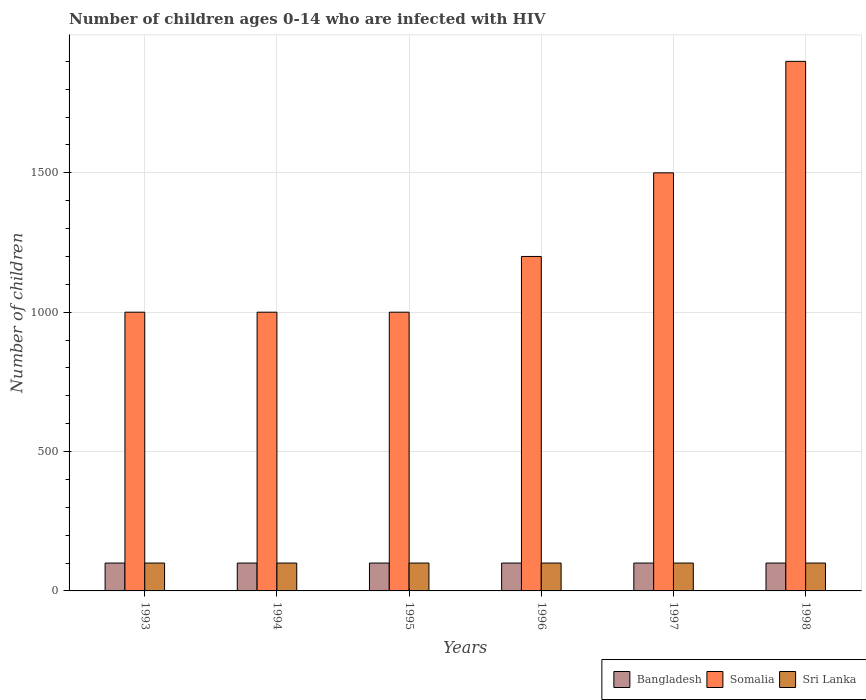Are the number of bars per tick equal to the number of legend labels?
Your answer should be very brief. Yes. How many bars are there on the 1st tick from the right?
Your response must be concise. 3. What is the label of the 2nd group of bars from the left?
Offer a very short reply. 1994. What is the number of HIV infected children in Sri Lanka in 1995?
Your answer should be compact. 100. Across all years, what is the maximum number of HIV infected children in Somalia?
Provide a succinct answer. 1900. Across all years, what is the minimum number of HIV infected children in Somalia?
Your answer should be compact. 1000. In which year was the number of HIV infected children in Bangladesh minimum?
Your answer should be compact. 1993. What is the total number of HIV infected children in Bangladesh in the graph?
Give a very brief answer. 600. What is the difference between the number of HIV infected children in Somalia in 1993 and the number of HIV infected children in Sri Lanka in 1997?
Provide a short and direct response. 900. What is the average number of HIV infected children in Somalia per year?
Your response must be concise. 1266.67. In how many years, is the number of HIV infected children in Somalia greater than 800?
Ensure brevity in your answer.  6. Is the difference between the number of HIV infected children in Bangladesh in 1994 and 1995 greater than the difference between the number of HIV infected children in Sri Lanka in 1994 and 1995?
Your response must be concise. No. In how many years, is the number of HIV infected children in Bangladesh greater than the average number of HIV infected children in Bangladesh taken over all years?
Offer a terse response. 0. What does the 2nd bar from the right in 1996 represents?
Your answer should be very brief. Somalia. Are all the bars in the graph horizontal?
Provide a succinct answer. No. How many years are there in the graph?
Provide a short and direct response. 6. Are the values on the major ticks of Y-axis written in scientific E-notation?
Provide a short and direct response. No. Does the graph contain any zero values?
Your answer should be compact. No. Does the graph contain grids?
Provide a succinct answer. Yes. How many legend labels are there?
Keep it short and to the point. 3. How are the legend labels stacked?
Offer a very short reply. Horizontal. What is the title of the graph?
Provide a succinct answer. Number of children ages 0-14 who are infected with HIV. What is the label or title of the Y-axis?
Offer a terse response. Number of children. What is the Number of children in Sri Lanka in 1993?
Ensure brevity in your answer.  100. What is the Number of children of Bangladesh in 1994?
Give a very brief answer. 100. What is the Number of children in Sri Lanka in 1994?
Make the answer very short. 100. What is the Number of children of Somalia in 1995?
Your answer should be very brief. 1000. What is the Number of children of Sri Lanka in 1995?
Ensure brevity in your answer.  100. What is the Number of children in Bangladesh in 1996?
Offer a terse response. 100. What is the Number of children in Somalia in 1996?
Ensure brevity in your answer.  1200. What is the Number of children of Sri Lanka in 1996?
Your answer should be compact. 100. What is the Number of children of Bangladesh in 1997?
Ensure brevity in your answer.  100. What is the Number of children in Somalia in 1997?
Your answer should be compact. 1500. What is the Number of children of Sri Lanka in 1997?
Keep it short and to the point. 100. What is the Number of children in Somalia in 1998?
Your response must be concise. 1900. What is the Number of children in Sri Lanka in 1998?
Offer a very short reply. 100. Across all years, what is the maximum Number of children of Somalia?
Make the answer very short. 1900. Across all years, what is the minimum Number of children of Somalia?
Your answer should be compact. 1000. What is the total Number of children of Bangladesh in the graph?
Provide a succinct answer. 600. What is the total Number of children of Somalia in the graph?
Your answer should be compact. 7600. What is the total Number of children in Sri Lanka in the graph?
Make the answer very short. 600. What is the difference between the Number of children in Bangladesh in 1993 and that in 1994?
Offer a terse response. 0. What is the difference between the Number of children in Somalia in 1993 and that in 1994?
Provide a succinct answer. 0. What is the difference between the Number of children of Somalia in 1993 and that in 1995?
Your answer should be compact. 0. What is the difference between the Number of children in Sri Lanka in 1993 and that in 1995?
Provide a succinct answer. 0. What is the difference between the Number of children of Bangladesh in 1993 and that in 1996?
Make the answer very short. 0. What is the difference between the Number of children of Somalia in 1993 and that in 1996?
Ensure brevity in your answer.  -200. What is the difference between the Number of children of Sri Lanka in 1993 and that in 1996?
Ensure brevity in your answer.  0. What is the difference between the Number of children of Somalia in 1993 and that in 1997?
Your answer should be compact. -500. What is the difference between the Number of children of Bangladesh in 1993 and that in 1998?
Provide a short and direct response. 0. What is the difference between the Number of children of Somalia in 1993 and that in 1998?
Keep it short and to the point. -900. What is the difference between the Number of children in Sri Lanka in 1993 and that in 1998?
Your answer should be compact. 0. What is the difference between the Number of children in Bangladesh in 1994 and that in 1995?
Give a very brief answer. 0. What is the difference between the Number of children in Sri Lanka in 1994 and that in 1995?
Your answer should be very brief. 0. What is the difference between the Number of children in Somalia in 1994 and that in 1996?
Provide a succinct answer. -200. What is the difference between the Number of children of Somalia in 1994 and that in 1997?
Provide a succinct answer. -500. What is the difference between the Number of children of Sri Lanka in 1994 and that in 1997?
Provide a short and direct response. 0. What is the difference between the Number of children of Somalia in 1994 and that in 1998?
Keep it short and to the point. -900. What is the difference between the Number of children in Sri Lanka in 1994 and that in 1998?
Your response must be concise. 0. What is the difference between the Number of children in Bangladesh in 1995 and that in 1996?
Offer a terse response. 0. What is the difference between the Number of children in Somalia in 1995 and that in 1996?
Your answer should be very brief. -200. What is the difference between the Number of children of Bangladesh in 1995 and that in 1997?
Provide a short and direct response. 0. What is the difference between the Number of children in Somalia in 1995 and that in 1997?
Give a very brief answer. -500. What is the difference between the Number of children in Bangladesh in 1995 and that in 1998?
Your response must be concise. 0. What is the difference between the Number of children in Somalia in 1995 and that in 1998?
Your response must be concise. -900. What is the difference between the Number of children of Bangladesh in 1996 and that in 1997?
Give a very brief answer. 0. What is the difference between the Number of children in Somalia in 1996 and that in 1997?
Provide a succinct answer. -300. What is the difference between the Number of children of Somalia in 1996 and that in 1998?
Your answer should be compact. -700. What is the difference between the Number of children of Somalia in 1997 and that in 1998?
Keep it short and to the point. -400. What is the difference between the Number of children of Sri Lanka in 1997 and that in 1998?
Offer a very short reply. 0. What is the difference between the Number of children in Bangladesh in 1993 and the Number of children in Somalia in 1994?
Your response must be concise. -900. What is the difference between the Number of children of Somalia in 1993 and the Number of children of Sri Lanka in 1994?
Your response must be concise. 900. What is the difference between the Number of children of Bangladesh in 1993 and the Number of children of Somalia in 1995?
Offer a very short reply. -900. What is the difference between the Number of children of Somalia in 1993 and the Number of children of Sri Lanka in 1995?
Offer a very short reply. 900. What is the difference between the Number of children of Bangladesh in 1993 and the Number of children of Somalia in 1996?
Ensure brevity in your answer.  -1100. What is the difference between the Number of children in Somalia in 1993 and the Number of children in Sri Lanka in 1996?
Your answer should be compact. 900. What is the difference between the Number of children in Bangladesh in 1993 and the Number of children in Somalia in 1997?
Make the answer very short. -1400. What is the difference between the Number of children of Bangladesh in 1993 and the Number of children of Sri Lanka in 1997?
Provide a short and direct response. 0. What is the difference between the Number of children of Somalia in 1993 and the Number of children of Sri Lanka in 1997?
Provide a short and direct response. 900. What is the difference between the Number of children in Bangladesh in 1993 and the Number of children in Somalia in 1998?
Keep it short and to the point. -1800. What is the difference between the Number of children in Somalia in 1993 and the Number of children in Sri Lanka in 1998?
Provide a succinct answer. 900. What is the difference between the Number of children in Bangladesh in 1994 and the Number of children in Somalia in 1995?
Give a very brief answer. -900. What is the difference between the Number of children of Bangladesh in 1994 and the Number of children of Sri Lanka in 1995?
Offer a terse response. 0. What is the difference between the Number of children of Somalia in 1994 and the Number of children of Sri Lanka in 1995?
Your answer should be very brief. 900. What is the difference between the Number of children of Bangladesh in 1994 and the Number of children of Somalia in 1996?
Provide a succinct answer. -1100. What is the difference between the Number of children of Somalia in 1994 and the Number of children of Sri Lanka in 1996?
Make the answer very short. 900. What is the difference between the Number of children of Bangladesh in 1994 and the Number of children of Somalia in 1997?
Your response must be concise. -1400. What is the difference between the Number of children of Somalia in 1994 and the Number of children of Sri Lanka in 1997?
Offer a very short reply. 900. What is the difference between the Number of children in Bangladesh in 1994 and the Number of children in Somalia in 1998?
Your answer should be very brief. -1800. What is the difference between the Number of children of Somalia in 1994 and the Number of children of Sri Lanka in 1998?
Your answer should be very brief. 900. What is the difference between the Number of children in Bangladesh in 1995 and the Number of children in Somalia in 1996?
Offer a terse response. -1100. What is the difference between the Number of children in Somalia in 1995 and the Number of children in Sri Lanka in 1996?
Give a very brief answer. 900. What is the difference between the Number of children in Bangladesh in 1995 and the Number of children in Somalia in 1997?
Ensure brevity in your answer.  -1400. What is the difference between the Number of children in Somalia in 1995 and the Number of children in Sri Lanka in 1997?
Offer a very short reply. 900. What is the difference between the Number of children in Bangladesh in 1995 and the Number of children in Somalia in 1998?
Provide a succinct answer. -1800. What is the difference between the Number of children in Somalia in 1995 and the Number of children in Sri Lanka in 1998?
Ensure brevity in your answer.  900. What is the difference between the Number of children in Bangladesh in 1996 and the Number of children in Somalia in 1997?
Offer a terse response. -1400. What is the difference between the Number of children of Bangladesh in 1996 and the Number of children of Sri Lanka in 1997?
Make the answer very short. 0. What is the difference between the Number of children of Somalia in 1996 and the Number of children of Sri Lanka in 1997?
Ensure brevity in your answer.  1100. What is the difference between the Number of children in Bangladesh in 1996 and the Number of children in Somalia in 1998?
Your answer should be very brief. -1800. What is the difference between the Number of children of Somalia in 1996 and the Number of children of Sri Lanka in 1998?
Provide a succinct answer. 1100. What is the difference between the Number of children in Bangladesh in 1997 and the Number of children in Somalia in 1998?
Offer a terse response. -1800. What is the difference between the Number of children of Bangladesh in 1997 and the Number of children of Sri Lanka in 1998?
Provide a succinct answer. 0. What is the difference between the Number of children of Somalia in 1997 and the Number of children of Sri Lanka in 1998?
Your answer should be compact. 1400. What is the average Number of children in Somalia per year?
Provide a succinct answer. 1266.67. What is the average Number of children in Sri Lanka per year?
Provide a succinct answer. 100. In the year 1993, what is the difference between the Number of children in Bangladesh and Number of children in Somalia?
Offer a terse response. -900. In the year 1993, what is the difference between the Number of children in Somalia and Number of children in Sri Lanka?
Offer a very short reply. 900. In the year 1994, what is the difference between the Number of children of Bangladesh and Number of children of Somalia?
Offer a terse response. -900. In the year 1994, what is the difference between the Number of children of Somalia and Number of children of Sri Lanka?
Ensure brevity in your answer.  900. In the year 1995, what is the difference between the Number of children in Bangladesh and Number of children in Somalia?
Your response must be concise. -900. In the year 1995, what is the difference between the Number of children in Somalia and Number of children in Sri Lanka?
Offer a very short reply. 900. In the year 1996, what is the difference between the Number of children in Bangladesh and Number of children in Somalia?
Your answer should be compact. -1100. In the year 1996, what is the difference between the Number of children in Somalia and Number of children in Sri Lanka?
Offer a very short reply. 1100. In the year 1997, what is the difference between the Number of children of Bangladesh and Number of children of Somalia?
Provide a short and direct response. -1400. In the year 1997, what is the difference between the Number of children in Somalia and Number of children in Sri Lanka?
Offer a terse response. 1400. In the year 1998, what is the difference between the Number of children of Bangladesh and Number of children of Somalia?
Make the answer very short. -1800. In the year 1998, what is the difference between the Number of children in Somalia and Number of children in Sri Lanka?
Your response must be concise. 1800. What is the ratio of the Number of children of Sri Lanka in 1993 to that in 1994?
Provide a short and direct response. 1. What is the ratio of the Number of children in Bangladesh in 1993 to that in 1995?
Provide a short and direct response. 1. What is the ratio of the Number of children of Somalia in 1993 to that in 1995?
Offer a very short reply. 1. What is the ratio of the Number of children of Sri Lanka in 1993 to that in 1995?
Your answer should be compact. 1. What is the ratio of the Number of children of Somalia in 1993 to that in 1997?
Provide a short and direct response. 0.67. What is the ratio of the Number of children in Somalia in 1993 to that in 1998?
Keep it short and to the point. 0.53. What is the ratio of the Number of children in Bangladesh in 1994 to that in 1995?
Offer a terse response. 1. What is the ratio of the Number of children of Somalia in 1994 to that in 1995?
Keep it short and to the point. 1. What is the ratio of the Number of children in Sri Lanka in 1994 to that in 1995?
Provide a succinct answer. 1. What is the ratio of the Number of children of Somalia in 1994 to that in 1996?
Your answer should be very brief. 0.83. What is the ratio of the Number of children in Sri Lanka in 1994 to that in 1996?
Your response must be concise. 1. What is the ratio of the Number of children of Somalia in 1994 to that in 1997?
Your response must be concise. 0.67. What is the ratio of the Number of children in Sri Lanka in 1994 to that in 1997?
Keep it short and to the point. 1. What is the ratio of the Number of children of Somalia in 1994 to that in 1998?
Give a very brief answer. 0.53. What is the ratio of the Number of children in Sri Lanka in 1995 to that in 1996?
Your response must be concise. 1. What is the ratio of the Number of children in Somalia in 1995 to that in 1997?
Keep it short and to the point. 0.67. What is the ratio of the Number of children of Sri Lanka in 1995 to that in 1997?
Offer a very short reply. 1. What is the ratio of the Number of children of Bangladesh in 1995 to that in 1998?
Offer a very short reply. 1. What is the ratio of the Number of children of Somalia in 1995 to that in 1998?
Make the answer very short. 0.53. What is the ratio of the Number of children of Sri Lanka in 1995 to that in 1998?
Ensure brevity in your answer.  1. What is the ratio of the Number of children of Sri Lanka in 1996 to that in 1997?
Ensure brevity in your answer.  1. What is the ratio of the Number of children in Somalia in 1996 to that in 1998?
Ensure brevity in your answer.  0.63. What is the ratio of the Number of children in Bangladesh in 1997 to that in 1998?
Offer a very short reply. 1. What is the ratio of the Number of children in Somalia in 1997 to that in 1998?
Offer a terse response. 0.79. What is the difference between the highest and the second highest Number of children in Somalia?
Make the answer very short. 400. What is the difference between the highest and the second highest Number of children of Sri Lanka?
Provide a succinct answer. 0. What is the difference between the highest and the lowest Number of children in Somalia?
Provide a short and direct response. 900. 